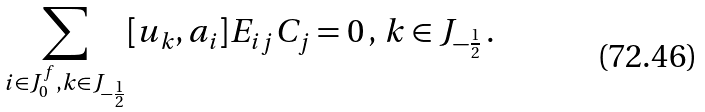Convert formula to latex. <formula><loc_0><loc_0><loc_500><loc_500>\sum _ { i \in J _ { 0 } ^ { f } , k \in J _ { - \frac { 1 } { 2 } } } [ u _ { k } , a _ { i } ] E _ { i j } C _ { j } = 0 \, , \, k \in J _ { - \frac { 1 } { 2 } } \, .</formula> 